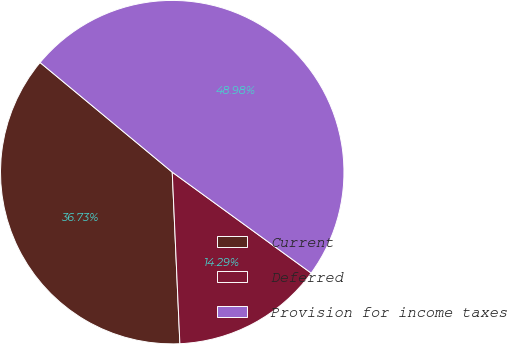Convert chart to OTSL. <chart><loc_0><loc_0><loc_500><loc_500><pie_chart><fcel>Current<fcel>Deferred<fcel>Provision for income taxes<nl><fcel>36.73%<fcel>14.29%<fcel>48.98%<nl></chart> 